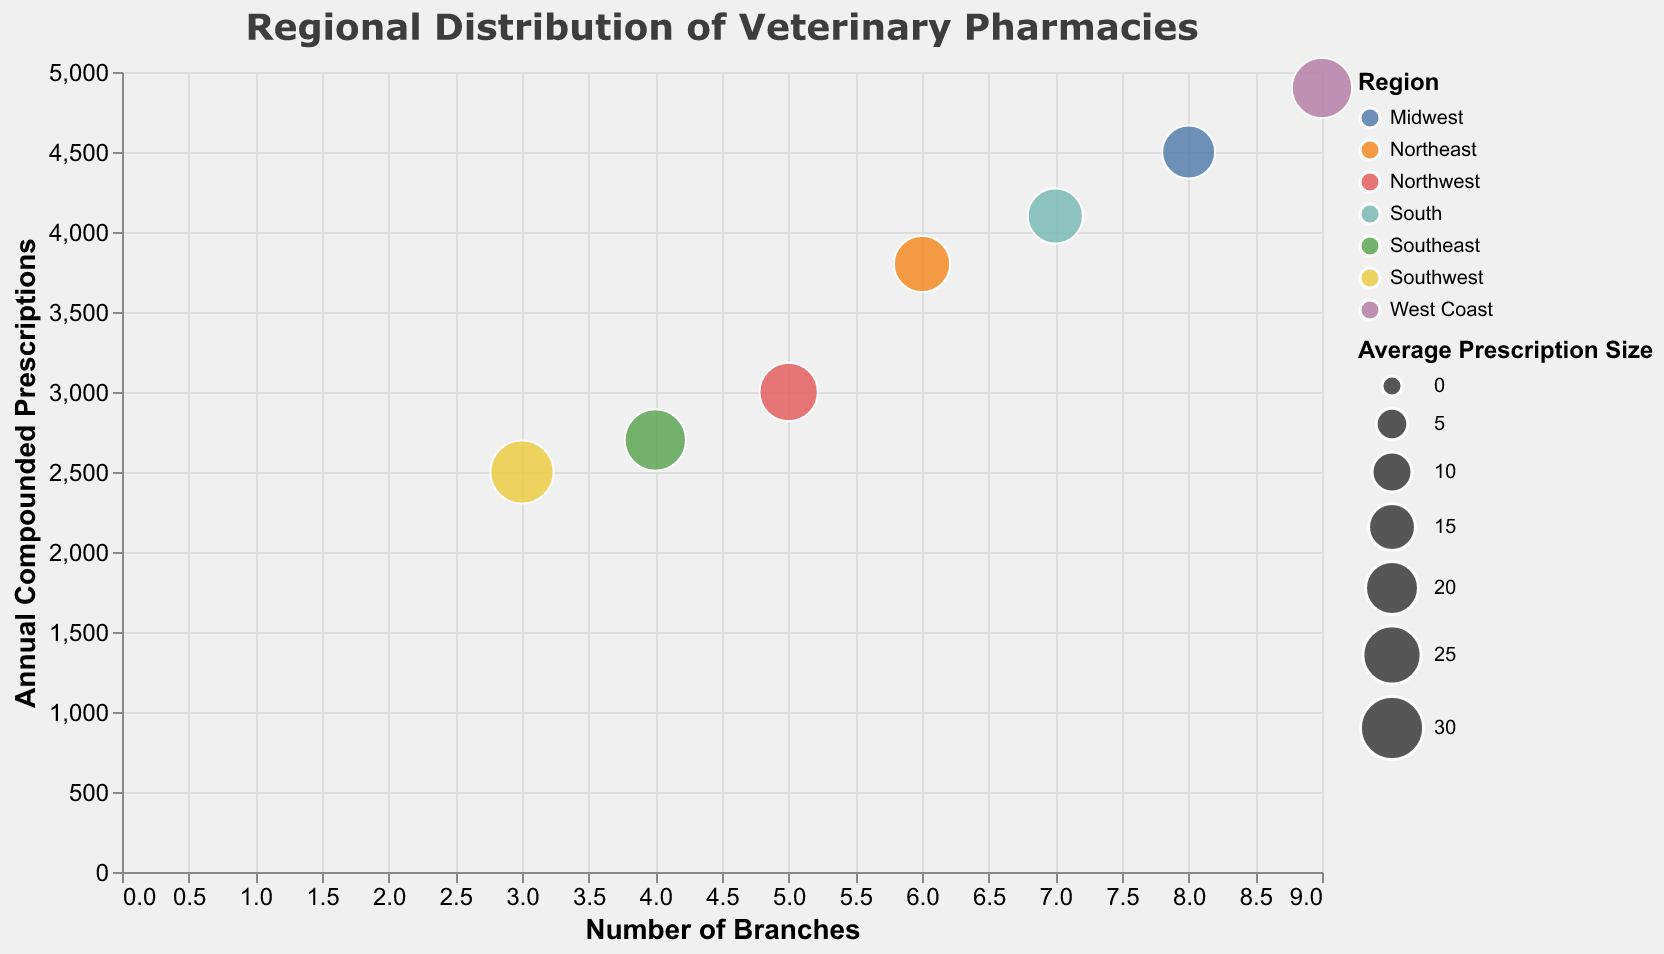Which region has the pharmacy with the highest number of branches? The color coding for the regions shows that Healthy Pets Compounding in the West Coast has the most branches at 9.
Answer: West Coast What's the average number of annual compounded prescriptions for pharmacies with 5 or more branches? The pharmacies with 5 or more branches are GreenLeaf Compounding Pharmacy (3000), Paws & Claws Compounding (4500), Happy Tails Compounding Pharmacy (3800), Pawfect Prescriptions (4100), and Healthy Pets Compounding (4900). The average is (3000 + 4500 + 3800 + 4100 + 4900) / 5 = 4060.
Answer: 4060 Which pharmacy has the smallest average prescription size? The 'size' legend shows that Paws & Claws Compounding in the Midwest has the smallest average prescription size at 20.
Answer: Paws & Claws Compounding Which region has the highest total annual compounded prescriptions from its pharmacies? Sum the annual compounded prescriptions for each region: 
- Northwest: 3000 
- Southwest: 2500 
- Midwest: 4500 
- Northeast: 3800 
- Southeast: 2700 
- South: 4100 
- West Coast: 4900, The West Coast has the highest total with 4900 prescriptions.
Answer: West Coast Compare Healthy Pets Compounding with Paws & Claws Compounding in terms of number of branches and average prescription size. Which one has a higher number of branches and which has a larger prescription size? Healthy Pets Compounding has 9 branches which is more than Paws & Claws Compounding's 8 branches. However, Paws & Claws Compounding has an average prescription size of 20, which is smaller compared to 27 for Healthy Pets Compounding.
Answer: Healthy Pets Compounding (branches), Healthy Pets Compounding (prescription size) What's the combined average prescription size for GreenLeaf Compounding Pharmacy and Happy Tails Compounding Pharmacy? GreenLeaf Compounding Pharmacy has an average prescription size of 25 and Happy Tails Compounding Pharmacy has 23. The combined average is (25+23)/2 = 24.
Answer: 24 Which pharmacy had approximately 4100 annual compounded prescriptions? Referring to the y-axis, Pawfect Prescriptions in the South had 4100 annual compounded prescriptions.
Answer: Pawfect Prescriptions What is the difference in annual compounded prescriptions between SafePaws Compounders and PetCare Pharmaceuticals? SafePaws Compounders had 2700 annual prescriptions while PetCare Pharmaceuticals had 2500. The difference is 2700 - 2500 = 200.
Answer: 200 